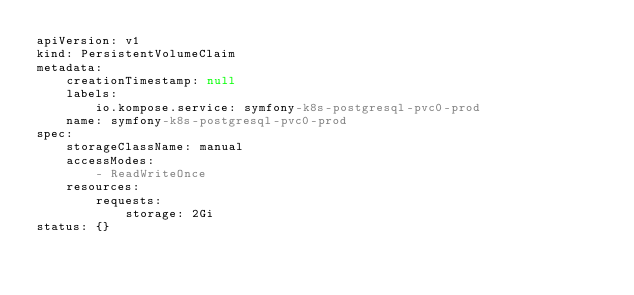Convert code to text. <code><loc_0><loc_0><loc_500><loc_500><_YAML_>apiVersion: v1
kind: PersistentVolumeClaim
metadata:
    creationTimestamp: null
    labels:
        io.kompose.service: symfony-k8s-postgresql-pvc0-prod
    name: symfony-k8s-postgresql-pvc0-prod
spec:
    storageClassName: manual
    accessModes:
        - ReadWriteOnce
    resources:
        requests:
            storage: 2Gi
status: {}</code> 